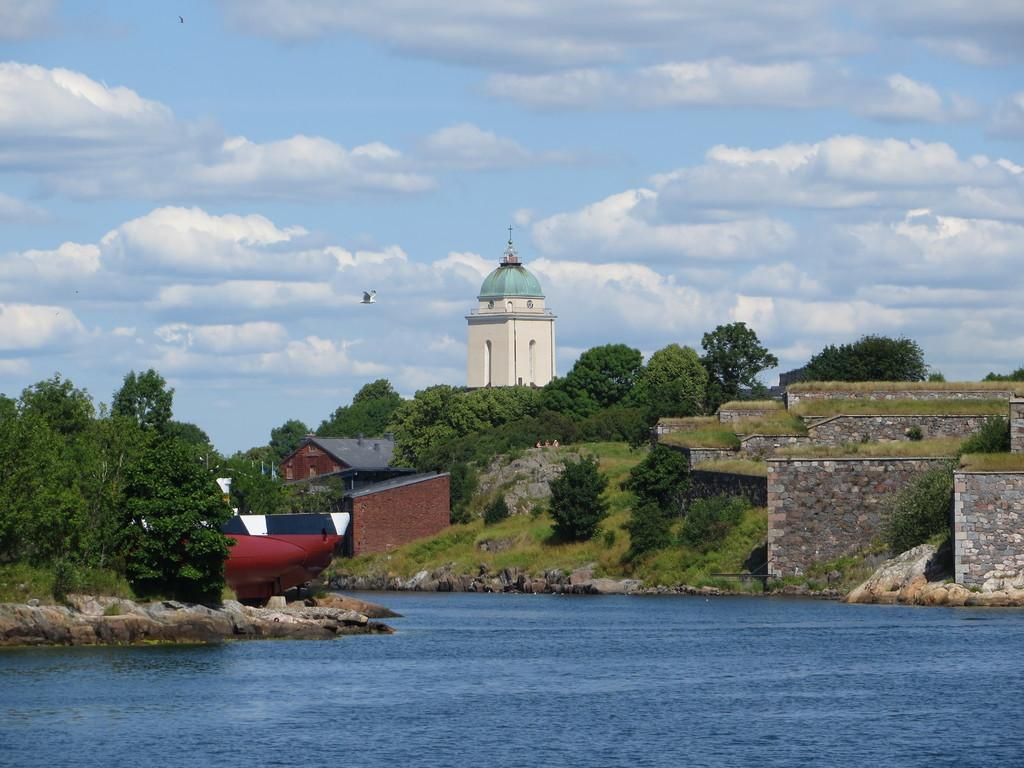What type of structures can be seen in the image? There are buildings in the image. What natural elements are present in the image? There are trees, grass, and water visible in the image. What architectural feature can be seen in the image? There is a wall in the image. What color object is present in the image? There is a maroon, white, and blue color object in the image. What can be seen in the sky in the image? The sky is visible in the image and is in white and blue color. What type of loaf is being used as a pen in the image? There is no loaf or pen present in the image. Where is the vacation destination in the image? The image does not depict a vacation destination; it features buildings, trees, grass, water, a wall, and a maroon, white, and blue color object. 